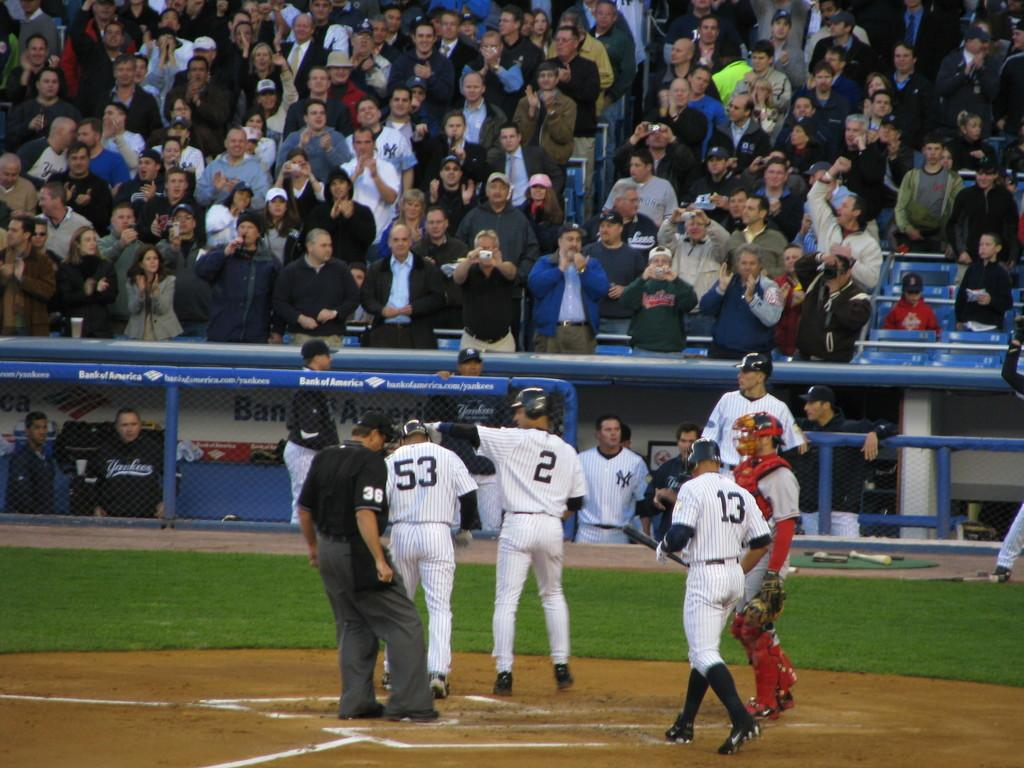<image>
Render a clear and concise summary of the photo. ny players  53, 2 13 at home base seem in good spirits in front of crowd in stands 